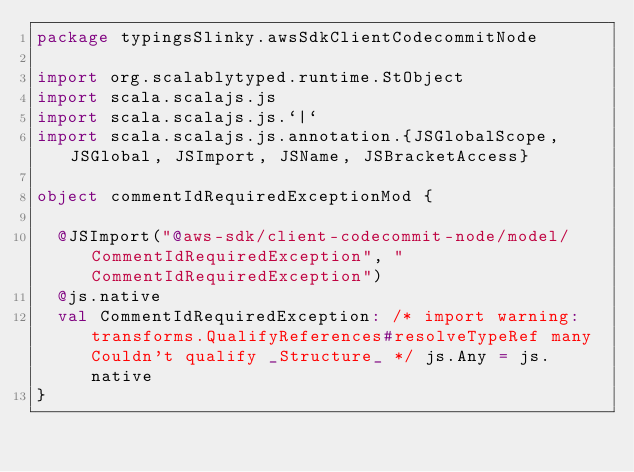Convert code to text. <code><loc_0><loc_0><loc_500><loc_500><_Scala_>package typingsSlinky.awsSdkClientCodecommitNode

import org.scalablytyped.runtime.StObject
import scala.scalajs.js
import scala.scalajs.js.`|`
import scala.scalajs.js.annotation.{JSGlobalScope, JSGlobal, JSImport, JSName, JSBracketAccess}

object commentIdRequiredExceptionMod {
  
  @JSImport("@aws-sdk/client-codecommit-node/model/CommentIdRequiredException", "CommentIdRequiredException")
  @js.native
  val CommentIdRequiredException: /* import warning: transforms.QualifyReferences#resolveTypeRef many Couldn't qualify _Structure_ */ js.Any = js.native
}
</code> 